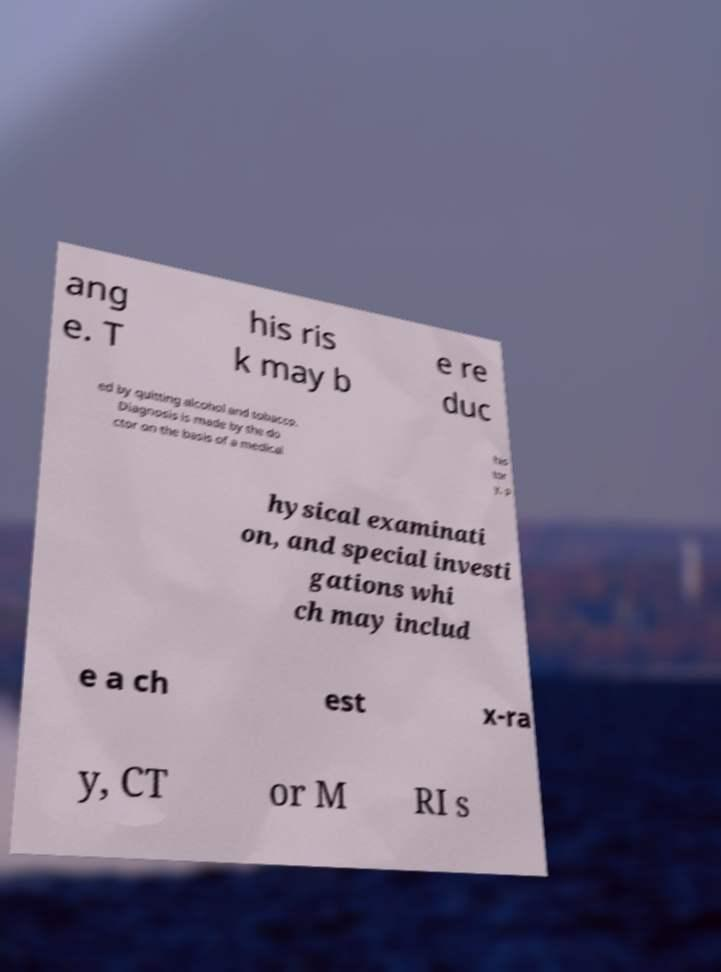Can you accurately transcribe the text from the provided image for me? ang e. T his ris k may b e re duc ed by quitting alcohol and tobacco. Diagnosis is made by the do ctor on the basis of a medical his tor y, p hysical examinati on, and special investi gations whi ch may includ e a ch est x-ra y, CT or M RI s 